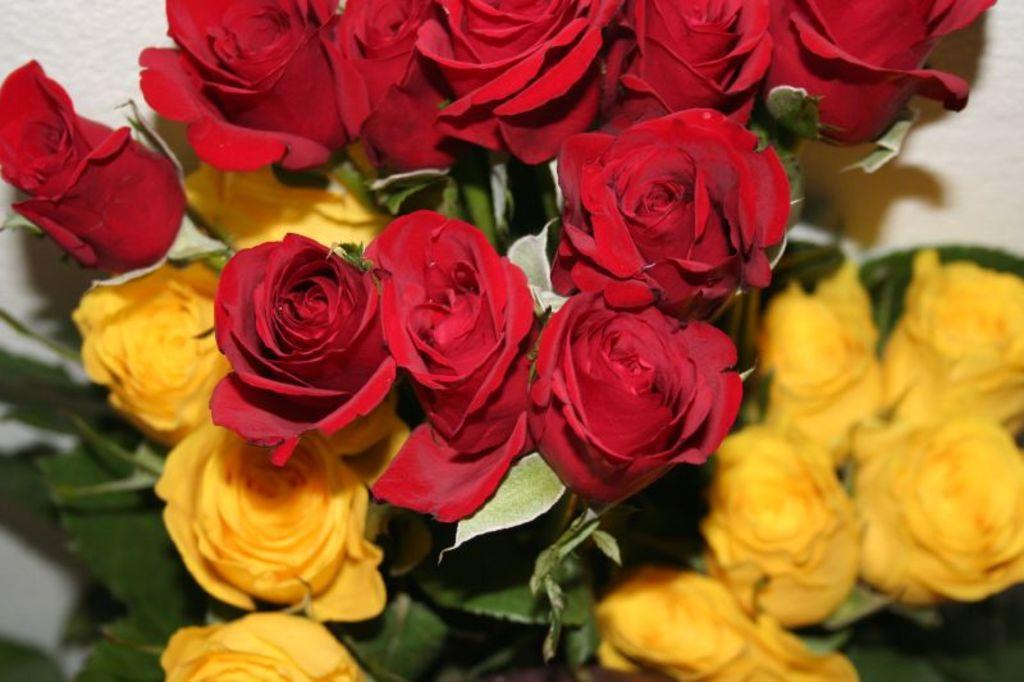In one or two sentences, can you explain what this image depicts? In the picture we can see a group of flowers to the plant, some flowers are red in color and some are yellow in color. 